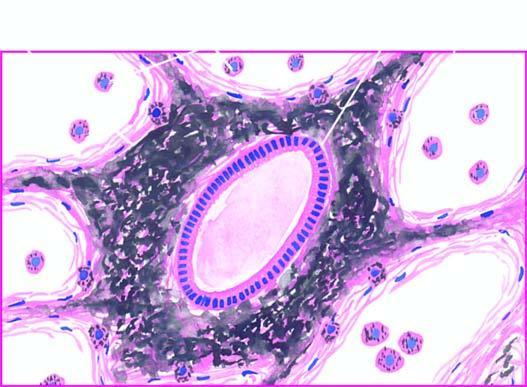what is there in the septal walls and around the bronchiole?
Answer the question using a single word or phrase. Presence of abundant coarse black carbon pigment bronchiole 